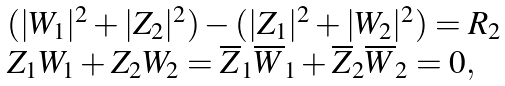<formula> <loc_0><loc_0><loc_500><loc_500>\begin{array} { l c r } { { ( | W _ { 1 } | ^ { 2 } + | Z _ { 2 } | ^ { 2 } ) - ( | Z _ { 1 } | ^ { 2 } + | W _ { 2 } | ^ { 2 } ) = R _ { 2 } } } \\ { { Z _ { 1 } W _ { 1 } + Z _ { 2 } W _ { 2 } = \overline { Z } _ { 1 } \overline { W } _ { 1 } + \overline { Z } _ { 2 } \overline { W } _ { 2 } = 0 , } } \end{array}</formula> 